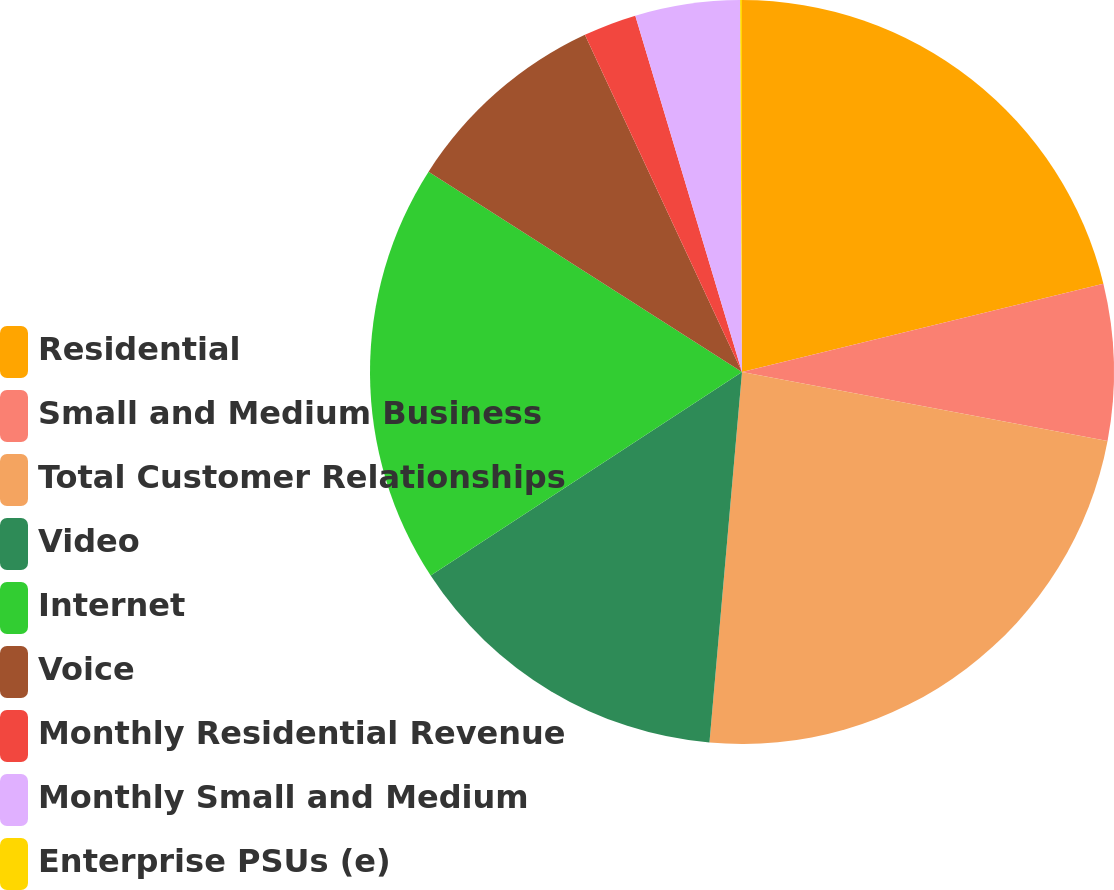<chart> <loc_0><loc_0><loc_500><loc_500><pie_chart><fcel>Residential<fcel>Small and Medium Business<fcel>Total Customer Relationships<fcel>Video<fcel>Internet<fcel>Voice<fcel>Monthly Residential Revenue<fcel>Monthly Small and Medium<fcel>Enterprise PSUs (e)<nl><fcel>21.19%<fcel>6.78%<fcel>23.43%<fcel>14.39%<fcel>18.27%<fcel>9.01%<fcel>2.31%<fcel>4.55%<fcel>0.08%<nl></chart> 